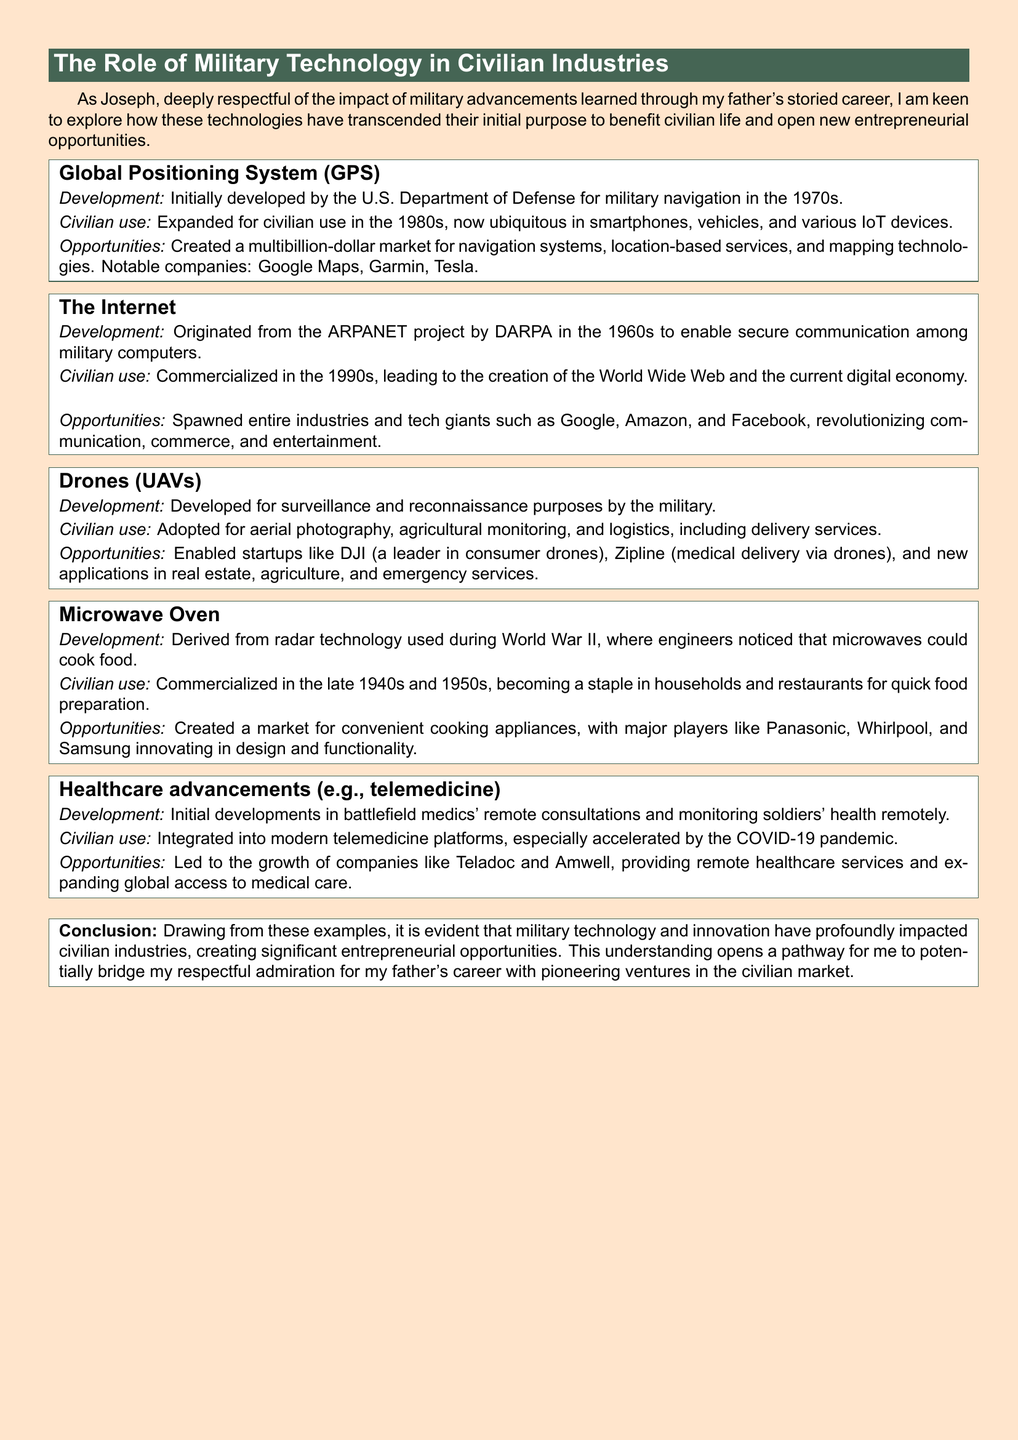What was the initial purpose of GPS? The document states that GPS was initially developed for military navigation by the U.S. Department of Defense.
Answer: military navigation In which decade did the Internet originate? The case study discusses the origins of the Internet from the ARPANET project, which began in the 1960s.
Answer: 1960s Name two notable companies that emerged from GPS technology. The document mentions Google Maps and Garmin as examples of companies that created a market through GPS technology.
Answer: Google Maps, Garmin What technology is derived from radar used during World War II? The case study explains that the microwave oven originated from radar technology utilized during World War II.
Answer: microwave oven How have drones adapted for civilian use? The document describes that drones have been adopted for aerial photography, agricultural monitoring, and logistics among other uses.
Answer: aerial photography, agricultural monitoring, logistics What significant growth in healthcare is mentioned? The case study highlights the growth of telemedicine platforms as a significant development in healthcare.
Answer: telemedicine What impact did military technology have on the entrepreneurial landscape? The conclusion states that military technology created significant entrepreneurial opportunities in civilian markets.
Answer: significant entrepreneurial opportunities Which military technology is linked to the delivery of healthcare services? The case study mentions that developments in telemedicine were originally designed for battlefield medics.
Answer: telemedicine Which company is identified as a leader in consumer drones? The document notes that DJI is a leader in the consumer drone market.
Answer: DJI 